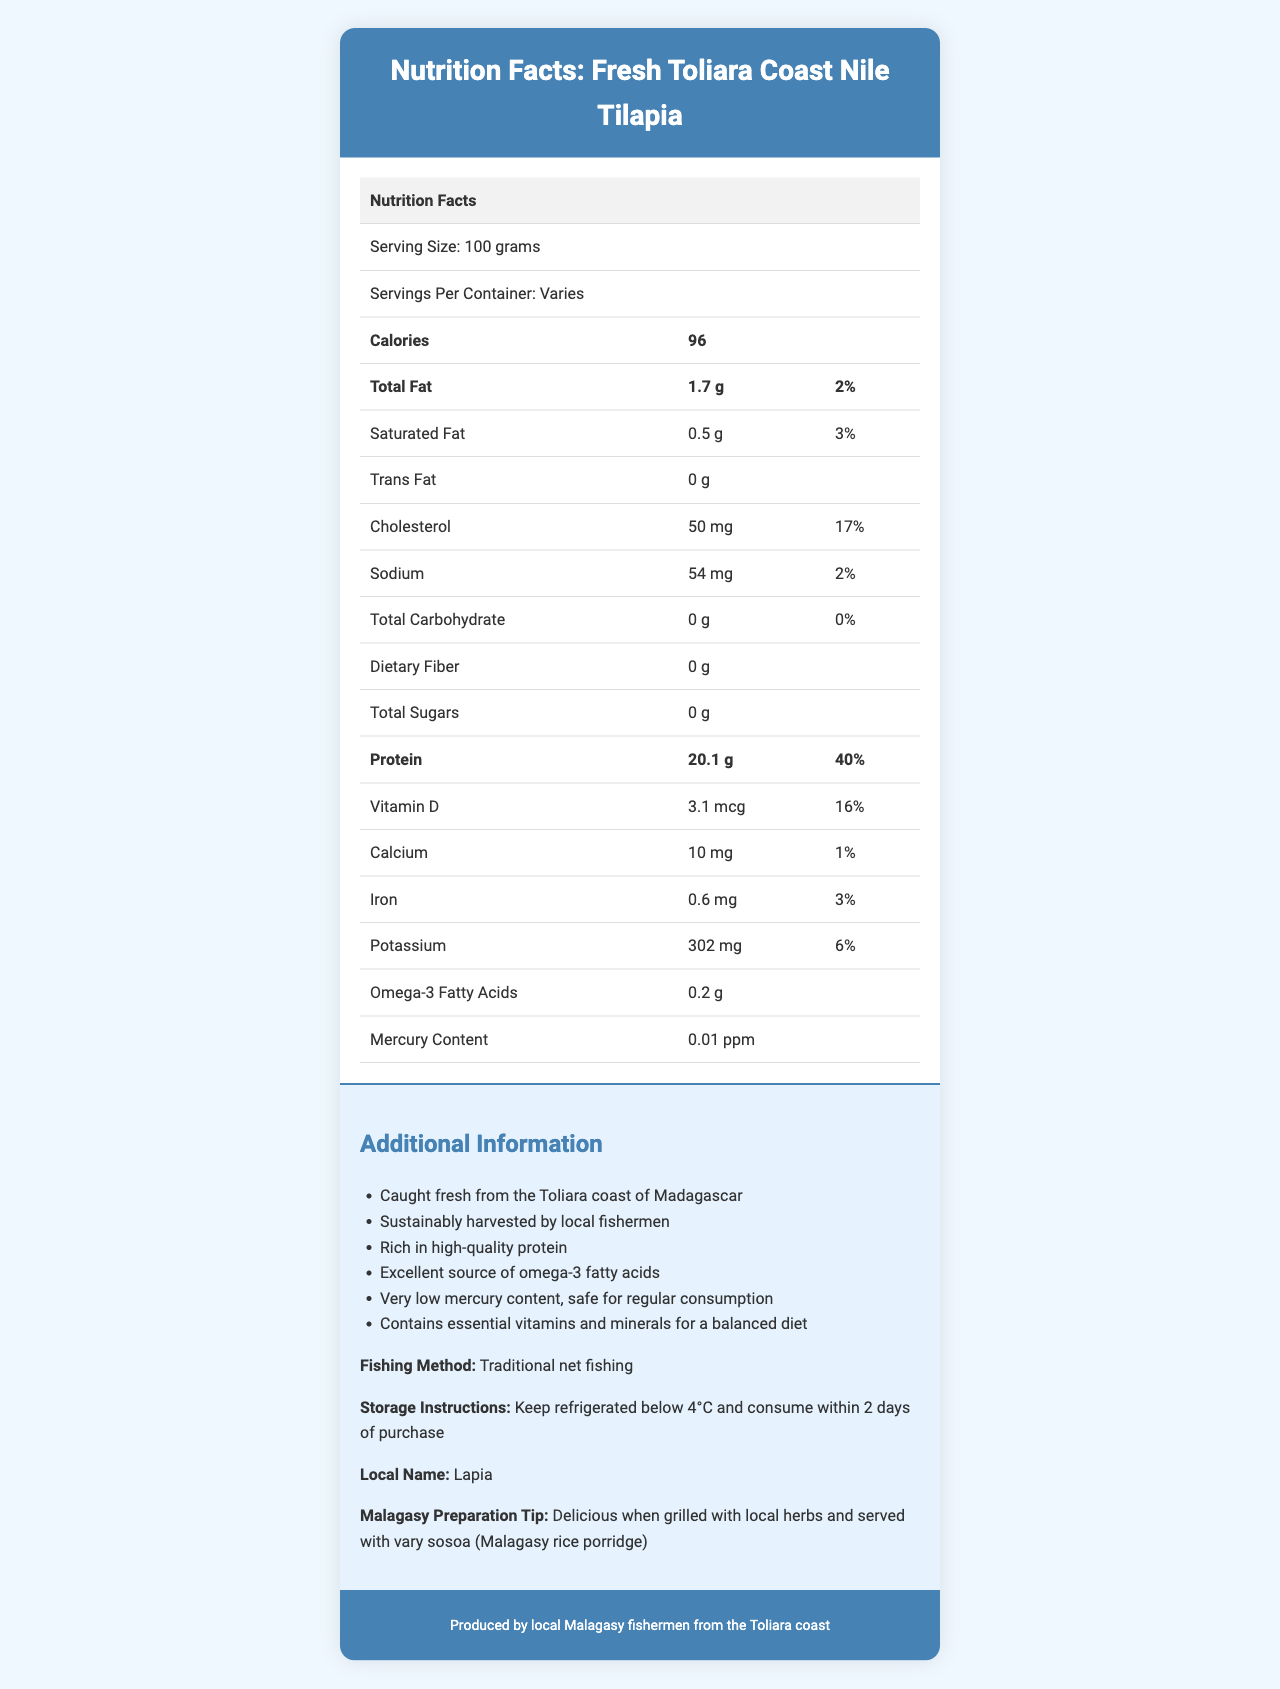What is the serving size of the Fresh Toliara Coast Nile Tilapia? The serving size is clearly stated in the document under the nutrition facts table.
Answer: 100 grams How much protein does one serving contain? According to the nutrition facts table, one serving contains 20.1 grams of protein.
Answer: 20.1 grams What is the daily value percentage of protein in one serving? The daily value percentage of protein is listed as 40% in the nutrition facts table.
Answer: 40% What is the mercury content of the Fresh Toliara Coast Nile Tilapia? The mercury content is listed as 0.01 ppm in the nutrition facts table.
Answer: 0.01 ppm What is the recommended way to store the Fresh Toliara Coast Nile Tilapia? The storage instructions provide this information.
Answer: Keep refrigerated below 4°C and consume within 2 days of purchase Is the Nile Tilapia rich in protein? The document states that the Nile Tilapia is rich in high-quality protein.
Answer: Yes Provide a summary of the nutrition and additional benefits of Fresh Toliara Coast Nile Tilapia. This summary integrates key points from the nutrition facts table and additional information sections of the document.
Answer: The Fresh Toliara Coast Nile Tilapia is a high-protein, low-fat fish with 20.1 grams of protein per 100-gram serving and very low mercury content (0.01 ppm). It provides essential nutrients like Vitamin D, calcium, iron, and potassium. It is sustainably caught using traditional methods and is safe for regular consumption due to its low mercury content. What is the fishing method used for catching the Nile Tilapia? The additional info section specifies that traditional net fishing is the method used.
Answer: Traditional net fishing What is the Omega-3 fatty acid content of one serving? The nutrition facts table lists omega-3 fatty acids per serving as 0.2 grams.
Answer: 0.2 grams Can you determine the source of the Nile Tilapia based on the document? The additional information section states that the fish is caught fresh from the Toliara coast of Madagascar.
Answer: Toliara coast of Madagascar How many calories are in one serving? The document lists the caloric content as 96 calories per 100-gram serving.
Answer: 96 calories Does the document specify any fiber content? The document lists dietary fiber as 0 grams, indicating there is no fiber content.
Answer: No 